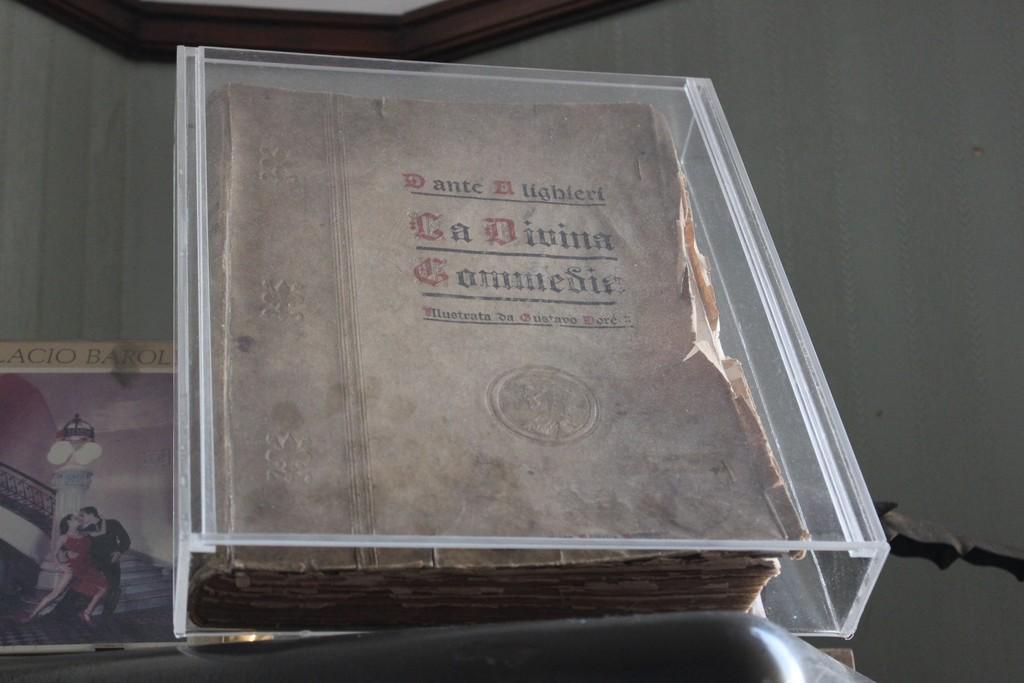Could you give a brief overview of what you see in this image? In this picture there is a book which is kept on the glass box, beside that we can see another book on the table. In the back we can see the walls. 